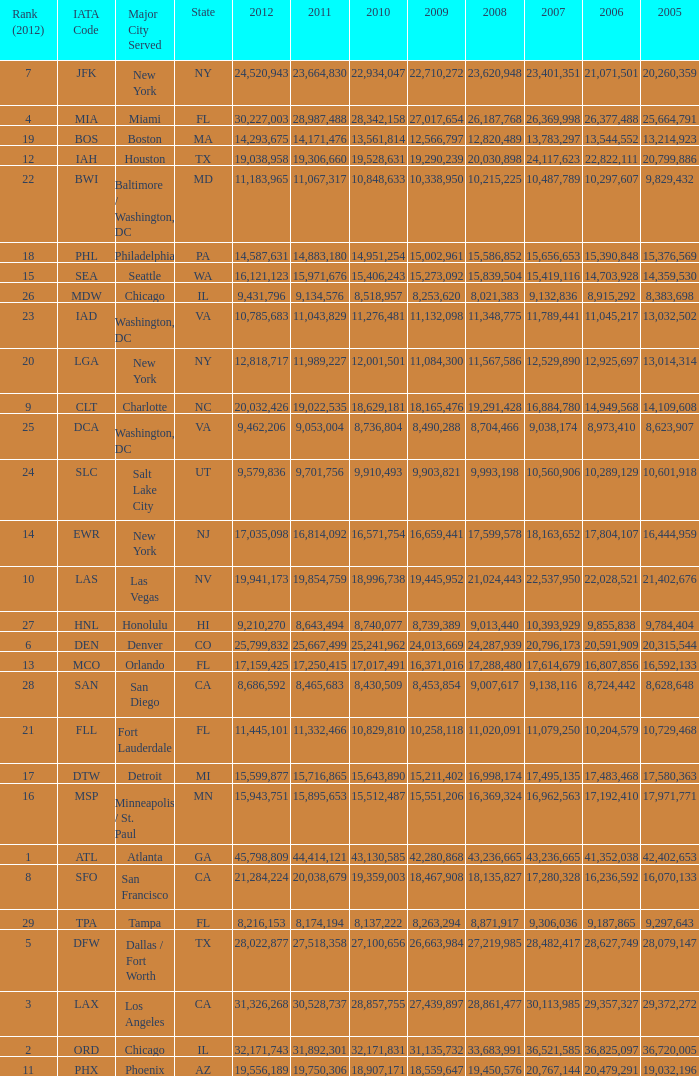For the IATA code of lax with 2009 less than 31,135,732 and 2011 less than 8,174,194, what is the sum of 2012? 0.0. 